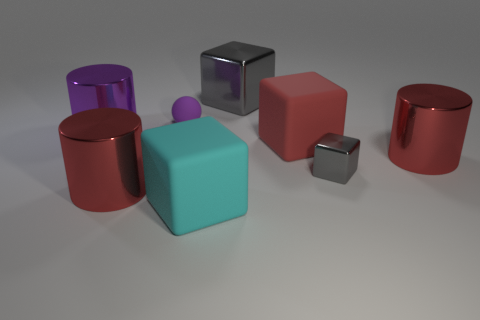There is a metal object that is the same color as the tiny ball; what size is it?
Provide a short and direct response. Large. There is a big cylinder that is the same color as the tiny ball; what is it made of?
Your answer should be compact. Metal. What number of small purple things have the same shape as the tiny gray metallic thing?
Your response must be concise. 0. The gray metallic object in front of the big matte block that is right of the metallic object that is behind the small purple ball is what shape?
Ensure brevity in your answer.  Cube. What material is the cylinder that is behind the tiny gray metallic object and on the left side of the purple rubber object?
Keep it short and to the point. Metal. There is a gray metallic object that is behind the purple metallic thing; does it have the same size as the tiny purple matte thing?
Make the answer very short. No. Is there any other thing that has the same size as the cyan object?
Offer a very short reply. Yes. Is the number of big metallic cubes that are on the right side of the red matte object greater than the number of small gray things behind the purple shiny object?
Ensure brevity in your answer.  No. The large matte cube that is in front of the rubber cube that is behind the big red metallic thing left of the small sphere is what color?
Offer a very short reply. Cyan. There is a metallic cylinder that is in front of the tiny metal object; is it the same color as the tiny metallic object?
Offer a terse response. No. 